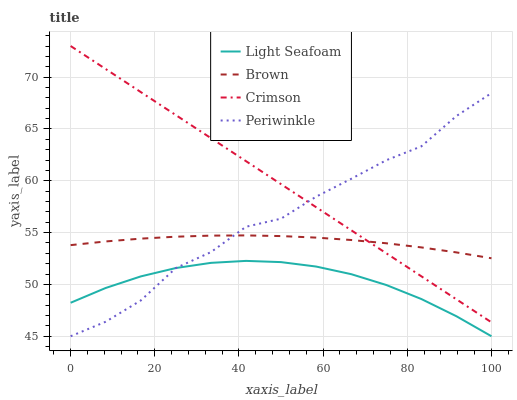Does Brown have the minimum area under the curve?
Answer yes or no. No. Does Brown have the maximum area under the curve?
Answer yes or no. No. Is Brown the smoothest?
Answer yes or no. No. Is Brown the roughest?
Answer yes or no. No. Does Brown have the lowest value?
Answer yes or no. No. Does Brown have the highest value?
Answer yes or no. No. Is Light Seafoam less than Crimson?
Answer yes or no. Yes. Is Brown greater than Light Seafoam?
Answer yes or no. Yes. Does Light Seafoam intersect Crimson?
Answer yes or no. No. 